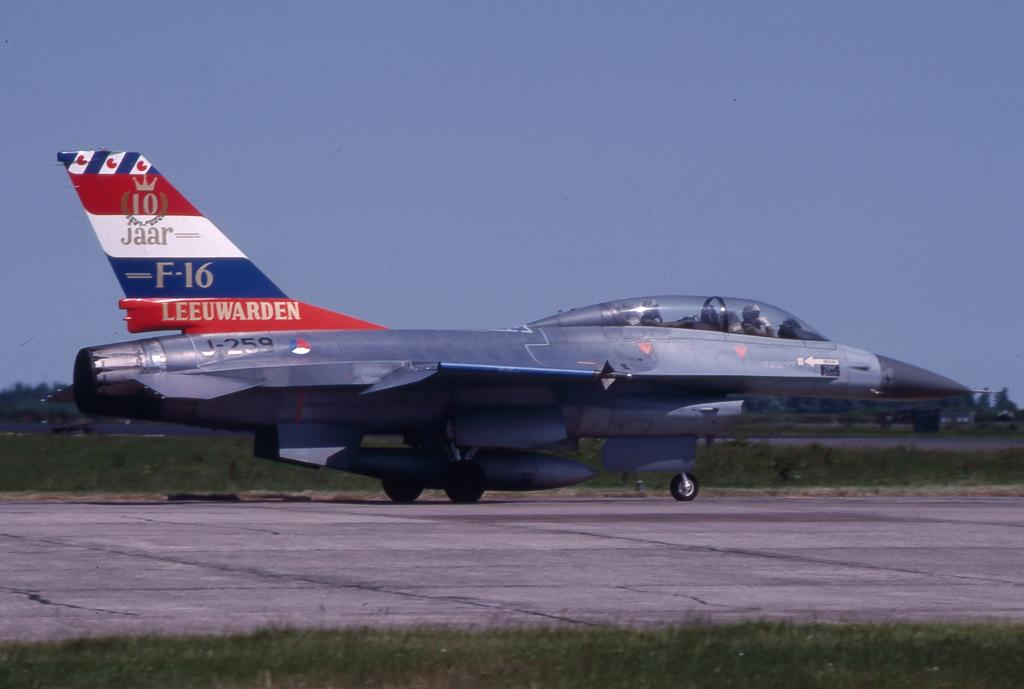Provide a one-sentence caption for the provided image. An airplaine from the airline Leeuwarde, it is an F-16. 